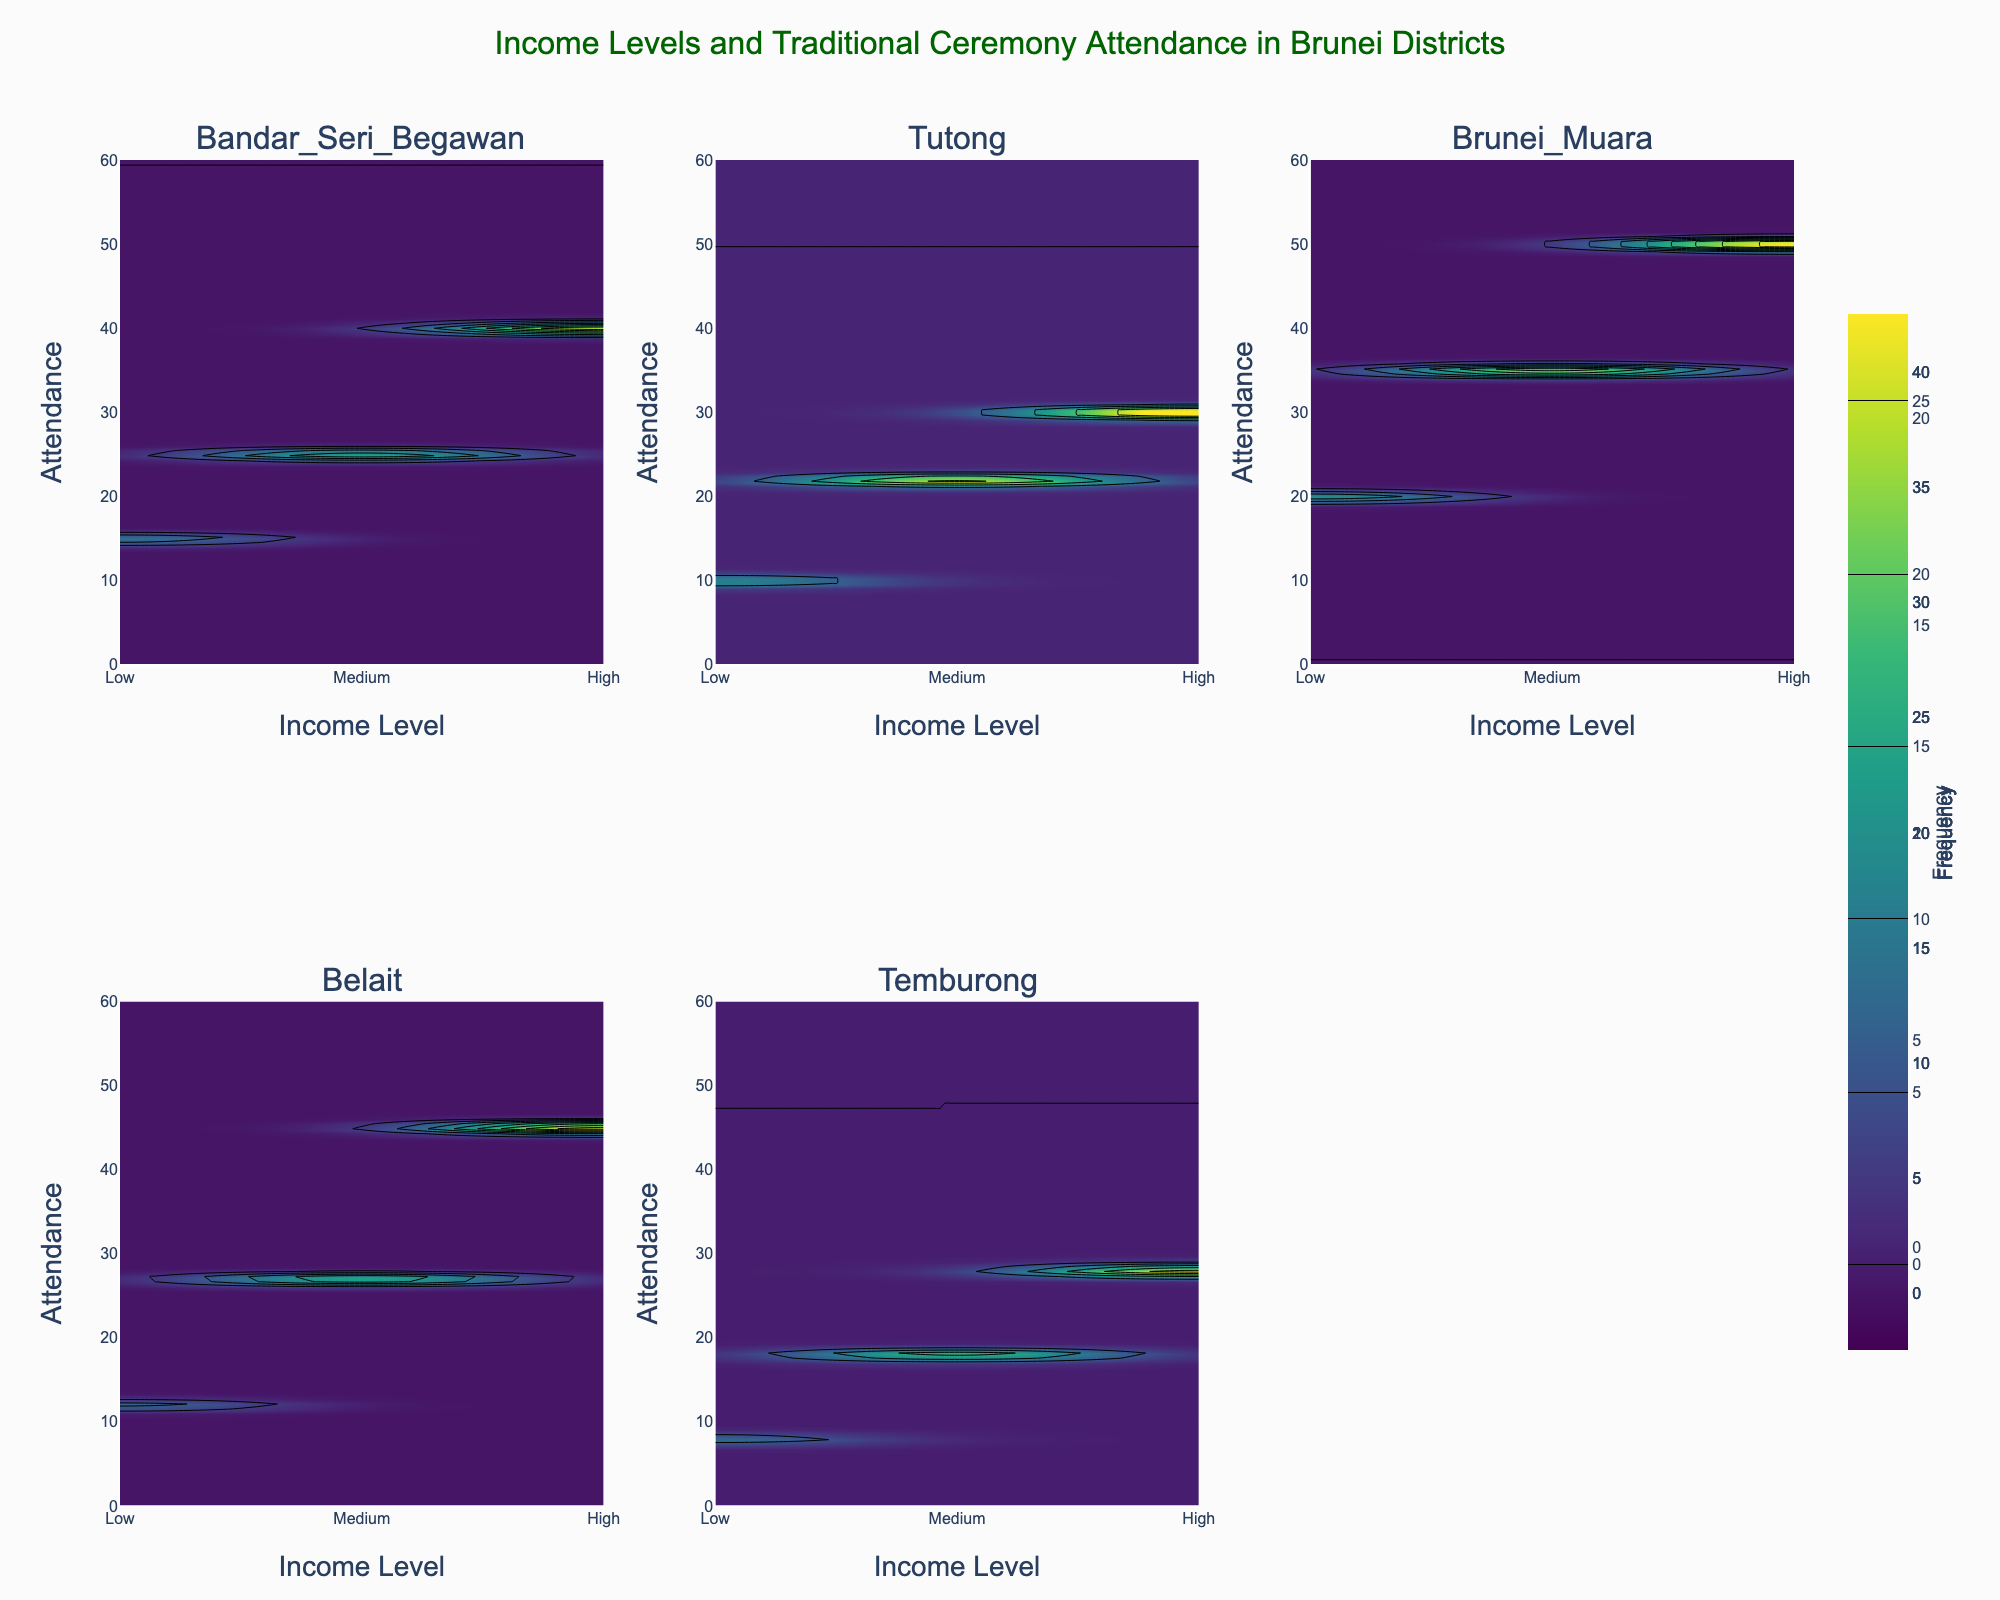How many subplots are there in the figure? The figure has individual contour plots for each district. Since the figure uses a 2x3 layout, there are six subplots, representing each of the districts in Brunei.
Answer: 6 Which district has the highest overall frequency of attendance for traditional ceremonies? When comparing the contour plots, the highest frequency of attendance across all income levels can be found in Brunei Muara, where the maximum attendance reaches up to 50.
Answer: Brunei Muara How does the attendance frequency in Tutong district compare between low and high income levels? In Tutong, the frequency of attendance for low-income levels is 10, whereas for high-income levels it is 30. Thus, the attendance frequency for high-income levels is 20 units higher than for low-income levels.
Answer: High-income levels have 20 units more attendance than low-income levels Which district has the lowest attendance frequency for traditional ceremonies among all income levels? The district with the lowest attendance frequency across all income levels can be identified by the lowest contour value. Temburong has the lowest attendance for low-income levels at 8 units.
Answer: Temburong What is the title of the entire figure? The title of the figure provides an overall description of the data being presented and is located at the top of the figure. It reads: "Income Levels and Traditional Ceremony Attendance in Brunei Districts."
Answer: Income Levels and Traditional Ceremony Attendance in Brunei Districts How does the frequency of attendance for medium income levels vary across different districts? To assess this, we look at the contour information for each district subplot corresponding to the 'Medium' income level. The attendance values for medium income levels are: Bandar Seri Begawan - 25, Tutong - 22, Brunei Muara - 35, Belait - 27, Temburong - 18.
Answer: Frequencies are 25, 22, 35, 27, and 18 What can be inferred about the relationship between income level and frequency of traditional ceremony attendance in Brunei Muara? The contour plot for Brunei Muara shows increasing frequency of attendance with higher income levels, from 20 for low-income to 50 for high-income. This suggests a positive correlation between income and attendance frequency in this district.
Answer: Positive correlation Which district shows the least variation in attendance frequency across different income levels? Variation can be assessed by evaluating the difference in attendance frequencies across income levels within each district. Tutong exhibits the least variation with values being 10 (Low), 22 (Medium), and 30 (High), showing a more moderate increase compared to other districts.
Answer: Tutong 